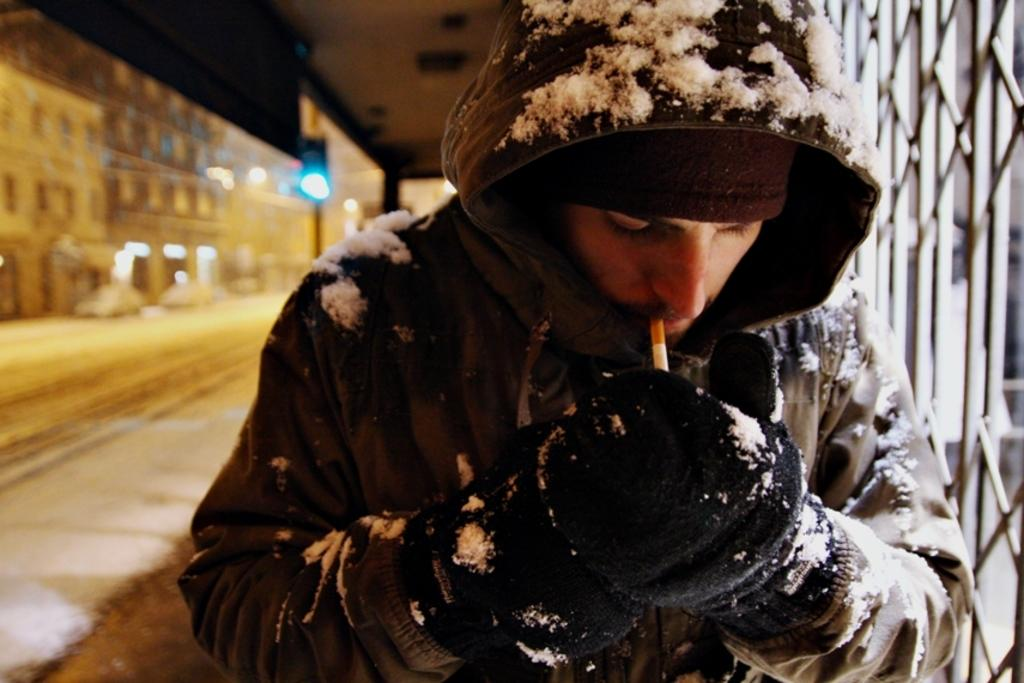Who is present in the image? There is a man in the image. What is the man wearing on his upper body? The man is wearing a jacket. What is the man wearing on his hands? The man is wearing gloves. What is the man holding in his mouth? The man is holding a cigarette in his mouth. What can be seen behind the man? There is a grille, a road, cars, and buildings behind the man. What type of ship can be seen transporting goods in the image? There is no ship present in the image; it features a man wearing a jacket, gloves, and holding a cigarette, along with a grille, road, cars, and buildings in the background. 